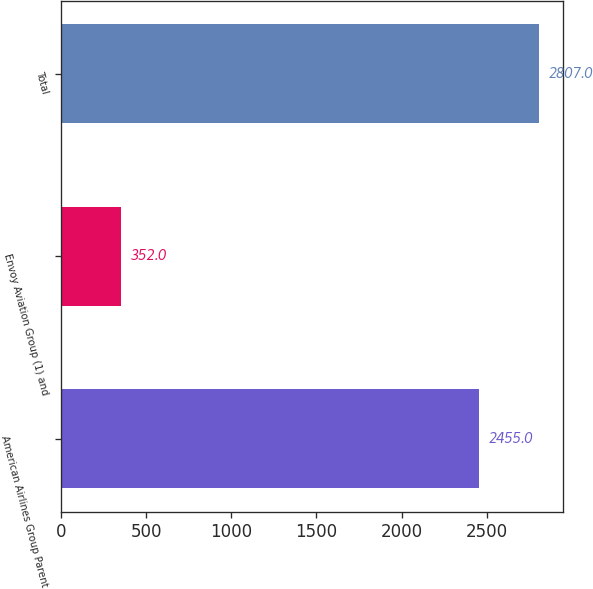<chart> <loc_0><loc_0><loc_500><loc_500><bar_chart><fcel>American Airlines Group Parent<fcel>Envoy Aviation Group (1) and<fcel>Total<nl><fcel>2455<fcel>352<fcel>2807<nl></chart> 